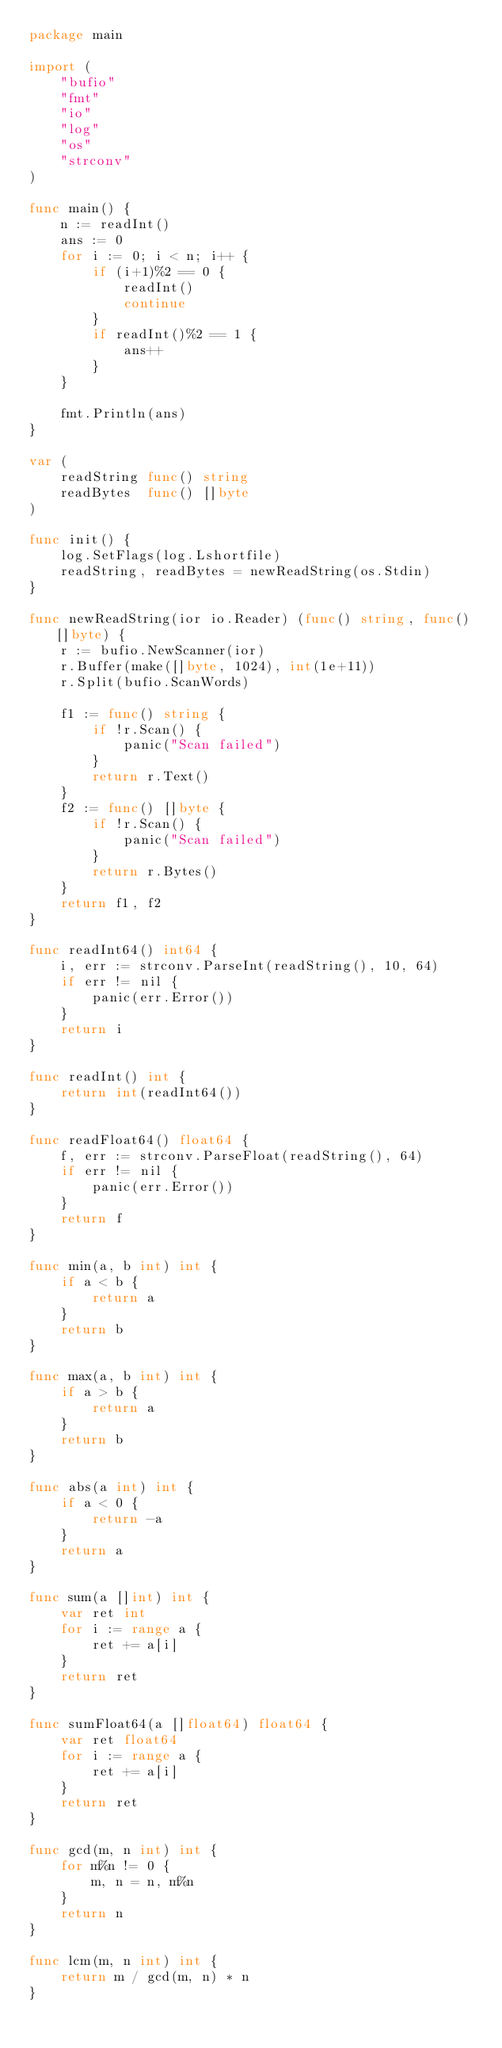Convert code to text. <code><loc_0><loc_0><loc_500><loc_500><_Go_>package main

import (
	"bufio"
	"fmt"
	"io"
	"log"
	"os"
	"strconv"
)

func main() {
	n := readInt()
	ans := 0
	for i := 0; i < n; i++ {
		if (i+1)%2 == 0 {
			readInt()
			continue
		}
		if readInt()%2 == 1 {
			ans++
		}
	}

	fmt.Println(ans)
}

var (
	readString func() string
	readBytes  func() []byte
)

func init() {
	log.SetFlags(log.Lshortfile)
	readString, readBytes = newReadString(os.Stdin)
}

func newReadString(ior io.Reader) (func() string, func() []byte) {
	r := bufio.NewScanner(ior)
	r.Buffer(make([]byte, 1024), int(1e+11))
	r.Split(bufio.ScanWords)

	f1 := func() string {
		if !r.Scan() {
			panic("Scan failed")
		}
		return r.Text()
	}
	f2 := func() []byte {
		if !r.Scan() {
			panic("Scan failed")
		}
		return r.Bytes()
	}
	return f1, f2
}

func readInt64() int64 {
	i, err := strconv.ParseInt(readString(), 10, 64)
	if err != nil {
		panic(err.Error())
	}
	return i
}

func readInt() int {
	return int(readInt64())
}

func readFloat64() float64 {
	f, err := strconv.ParseFloat(readString(), 64)
	if err != nil {
		panic(err.Error())
	}
	return f
}

func min(a, b int) int {
	if a < b {
		return a
	}
	return b
}

func max(a, b int) int {
	if a > b {
		return a
	}
	return b
}

func abs(a int) int {
	if a < 0 {
		return -a
	}
	return a
}

func sum(a []int) int {
	var ret int
	for i := range a {
		ret += a[i]
	}
	return ret
}

func sumFloat64(a []float64) float64 {
	var ret float64
	for i := range a {
		ret += a[i]
	}
	return ret
}

func gcd(m, n int) int {
	for m%n != 0 {
		m, n = n, m%n
	}
	return n
}

func lcm(m, n int) int {
	return m / gcd(m, n) * n
}
</code> 